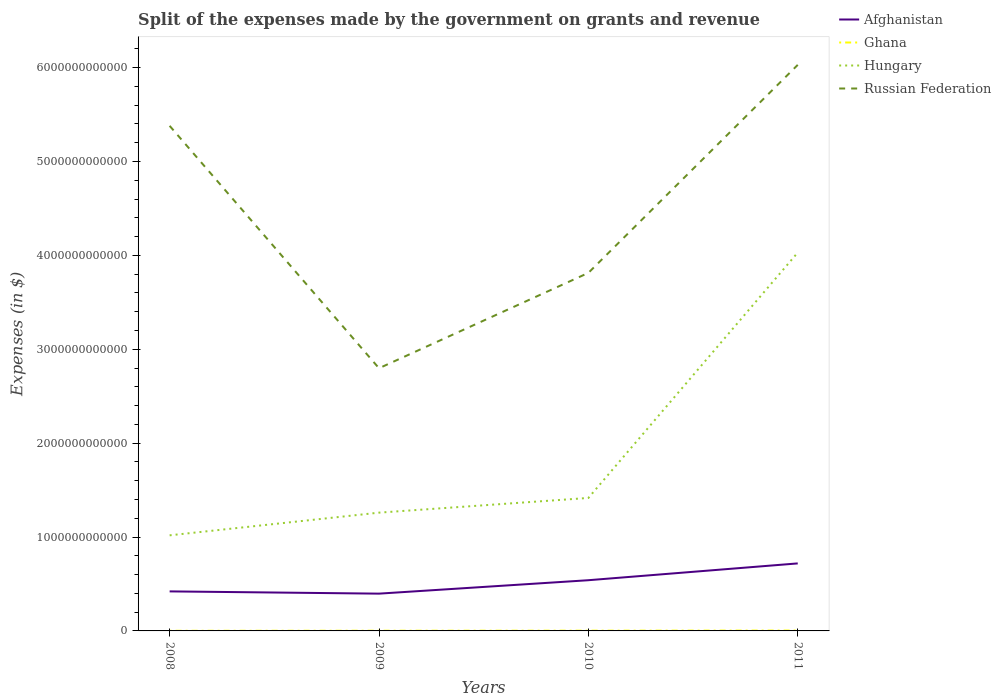How many different coloured lines are there?
Offer a very short reply. 4. Is the number of lines equal to the number of legend labels?
Make the answer very short. Yes. Across all years, what is the maximum expenses made by the government on grants and revenue in Russian Federation?
Provide a succinct answer. 2.80e+12. What is the total expenses made by the government on grants and revenue in Afghanistan in the graph?
Make the answer very short. -1.19e+11. What is the difference between the highest and the second highest expenses made by the government on grants and revenue in Hungary?
Give a very brief answer. 3.01e+12. Is the expenses made by the government on grants and revenue in Russian Federation strictly greater than the expenses made by the government on grants and revenue in Ghana over the years?
Your response must be concise. No. How many lines are there?
Ensure brevity in your answer.  4. What is the difference between two consecutive major ticks on the Y-axis?
Make the answer very short. 1.00e+12. Are the values on the major ticks of Y-axis written in scientific E-notation?
Provide a succinct answer. No. How many legend labels are there?
Provide a succinct answer. 4. What is the title of the graph?
Your response must be concise. Split of the expenses made by the government on grants and revenue. What is the label or title of the X-axis?
Your response must be concise. Years. What is the label or title of the Y-axis?
Provide a short and direct response. Expenses (in $). What is the Expenses (in $) in Afghanistan in 2008?
Offer a very short reply. 4.21e+11. What is the Expenses (in $) in Ghana in 2008?
Your answer should be very brief. 1.44e+09. What is the Expenses (in $) of Hungary in 2008?
Provide a succinct answer. 1.02e+12. What is the Expenses (in $) in Russian Federation in 2008?
Offer a very short reply. 5.38e+12. What is the Expenses (in $) in Afghanistan in 2009?
Give a very brief answer. 3.97e+11. What is the Expenses (in $) in Ghana in 2009?
Offer a very short reply. 2.19e+09. What is the Expenses (in $) of Hungary in 2009?
Give a very brief answer. 1.26e+12. What is the Expenses (in $) of Russian Federation in 2009?
Make the answer very short. 2.80e+12. What is the Expenses (in $) of Afghanistan in 2010?
Your answer should be compact. 5.40e+11. What is the Expenses (in $) in Ghana in 2010?
Offer a terse response. 2.69e+09. What is the Expenses (in $) of Hungary in 2010?
Provide a short and direct response. 1.42e+12. What is the Expenses (in $) of Russian Federation in 2010?
Keep it short and to the point. 3.81e+12. What is the Expenses (in $) of Afghanistan in 2011?
Ensure brevity in your answer.  7.19e+11. What is the Expenses (in $) of Ghana in 2011?
Make the answer very short. 3.96e+09. What is the Expenses (in $) of Hungary in 2011?
Keep it short and to the point. 4.03e+12. What is the Expenses (in $) in Russian Federation in 2011?
Make the answer very short. 6.03e+12. Across all years, what is the maximum Expenses (in $) in Afghanistan?
Give a very brief answer. 7.19e+11. Across all years, what is the maximum Expenses (in $) in Ghana?
Give a very brief answer. 3.96e+09. Across all years, what is the maximum Expenses (in $) of Hungary?
Offer a very short reply. 4.03e+12. Across all years, what is the maximum Expenses (in $) in Russian Federation?
Your response must be concise. 6.03e+12. Across all years, what is the minimum Expenses (in $) of Afghanistan?
Provide a succinct answer. 3.97e+11. Across all years, what is the minimum Expenses (in $) in Ghana?
Your answer should be very brief. 1.44e+09. Across all years, what is the minimum Expenses (in $) in Hungary?
Offer a very short reply. 1.02e+12. Across all years, what is the minimum Expenses (in $) in Russian Federation?
Your response must be concise. 2.80e+12. What is the total Expenses (in $) of Afghanistan in the graph?
Ensure brevity in your answer.  2.08e+12. What is the total Expenses (in $) in Ghana in the graph?
Keep it short and to the point. 1.03e+1. What is the total Expenses (in $) in Hungary in the graph?
Keep it short and to the point. 7.72e+12. What is the total Expenses (in $) of Russian Federation in the graph?
Keep it short and to the point. 1.80e+13. What is the difference between the Expenses (in $) of Afghanistan in 2008 and that in 2009?
Provide a short and direct response. 2.40e+1. What is the difference between the Expenses (in $) in Ghana in 2008 and that in 2009?
Offer a very short reply. -7.46e+08. What is the difference between the Expenses (in $) of Hungary in 2008 and that in 2009?
Offer a very short reply. -2.42e+11. What is the difference between the Expenses (in $) of Russian Federation in 2008 and that in 2009?
Make the answer very short. 2.58e+12. What is the difference between the Expenses (in $) in Afghanistan in 2008 and that in 2010?
Offer a very short reply. -1.19e+11. What is the difference between the Expenses (in $) of Ghana in 2008 and that in 2010?
Your response must be concise. -1.25e+09. What is the difference between the Expenses (in $) of Hungary in 2008 and that in 2010?
Provide a short and direct response. -3.98e+11. What is the difference between the Expenses (in $) of Russian Federation in 2008 and that in 2010?
Make the answer very short. 1.57e+12. What is the difference between the Expenses (in $) in Afghanistan in 2008 and that in 2011?
Make the answer very short. -2.98e+11. What is the difference between the Expenses (in $) of Ghana in 2008 and that in 2011?
Ensure brevity in your answer.  -2.52e+09. What is the difference between the Expenses (in $) of Hungary in 2008 and that in 2011?
Your answer should be very brief. -3.01e+12. What is the difference between the Expenses (in $) in Russian Federation in 2008 and that in 2011?
Keep it short and to the point. -6.49e+11. What is the difference between the Expenses (in $) in Afghanistan in 2009 and that in 2010?
Your answer should be compact. -1.43e+11. What is the difference between the Expenses (in $) of Ghana in 2009 and that in 2010?
Keep it short and to the point. -5.08e+08. What is the difference between the Expenses (in $) of Hungary in 2009 and that in 2010?
Ensure brevity in your answer.  -1.57e+11. What is the difference between the Expenses (in $) of Russian Federation in 2009 and that in 2010?
Keep it short and to the point. -1.02e+12. What is the difference between the Expenses (in $) in Afghanistan in 2009 and that in 2011?
Your answer should be compact. -3.22e+11. What is the difference between the Expenses (in $) in Ghana in 2009 and that in 2011?
Your response must be concise. -1.78e+09. What is the difference between the Expenses (in $) in Hungary in 2009 and that in 2011?
Your answer should be very brief. -2.77e+12. What is the difference between the Expenses (in $) in Russian Federation in 2009 and that in 2011?
Ensure brevity in your answer.  -3.23e+12. What is the difference between the Expenses (in $) in Afghanistan in 2010 and that in 2011?
Give a very brief answer. -1.79e+11. What is the difference between the Expenses (in $) of Ghana in 2010 and that in 2011?
Offer a very short reply. -1.27e+09. What is the difference between the Expenses (in $) in Hungary in 2010 and that in 2011?
Offer a terse response. -2.61e+12. What is the difference between the Expenses (in $) in Russian Federation in 2010 and that in 2011?
Give a very brief answer. -2.22e+12. What is the difference between the Expenses (in $) of Afghanistan in 2008 and the Expenses (in $) of Ghana in 2009?
Ensure brevity in your answer.  4.19e+11. What is the difference between the Expenses (in $) of Afghanistan in 2008 and the Expenses (in $) of Hungary in 2009?
Provide a short and direct response. -8.39e+11. What is the difference between the Expenses (in $) in Afghanistan in 2008 and the Expenses (in $) in Russian Federation in 2009?
Make the answer very short. -2.38e+12. What is the difference between the Expenses (in $) in Ghana in 2008 and the Expenses (in $) in Hungary in 2009?
Your answer should be compact. -1.26e+12. What is the difference between the Expenses (in $) in Ghana in 2008 and the Expenses (in $) in Russian Federation in 2009?
Your answer should be compact. -2.80e+12. What is the difference between the Expenses (in $) of Hungary in 2008 and the Expenses (in $) of Russian Federation in 2009?
Your answer should be compact. -1.78e+12. What is the difference between the Expenses (in $) of Afghanistan in 2008 and the Expenses (in $) of Ghana in 2010?
Make the answer very short. 4.18e+11. What is the difference between the Expenses (in $) in Afghanistan in 2008 and the Expenses (in $) in Hungary in 2010?
Make the answer very short. -9.95e+11. What is the difference between the Expenses (in $) of Afghanistan in 2008 and the Expenses (in $) of Russian Federation in 2010?
Provide a short and direct response. -3.39e+12. What is the difference between the Expenses (in $) of Ghana in 2008 and the Expenses (in $) of Hungary in 2010?
Keep it short and to the point. -1.42e+12. What is the difference between the Expenses (in $) of Ghana in 2008 and the Expenses (in $) of Russian Federation in 2010?
Ensure brevity in your answer.  -3.81e+12. What is the difference between the Expenses (in $) in Hungary in 2008 and the Expenses (in $) in Russian Federation in 2010?
Make the answer very short. -2.80e+12. What is the difference between the Expenses (in $) of Afghanistan in 2008 and the Expenses (in $) of Ghana in 2011?
Provide a short and direct response. 4.17e+11. What is the difference between the Expenses (in $) of Afghanistan in 2008 and the Expenses (in $) of Hungary in 2011?
Your answer should be very brief. -3.61e+12. What is the difference between the Expenses (in $) in Afghanistan in 2008 and the Expenses (in $) in Russian Federation in 2011?
Your response must be concise. -5.61e+12. What is the difference between the Expenses (in $) in Ghana in 2008 and the Expenses (in $) in Hungary in 2011?
Make the answer very short. -4.03e+12. What is the difference between the Expenses (in $) in Ghana in 2008 and the Expenses (in $) in Russian Federation in 2011?
Offer a terse response. -6.03e+12. What is the difference between the Expenses (in $) in Hungary in 2008 and the Expenses (in $) in Russian Federation in 2011?
Offer a very short reply. -5.01e+12. What is the difference between the Expenses (in $) in Afghanistan in 2009 and the Expenses (in $) in Ghana in 2010?
Keep it short and to the point. 3.94e+11. What is the difference between the Expenses (in $) of Afghanistan in 2009 and the Expenses (in $) of Hungary in 2010?
Your answer should be very brief. -1.02e+12. What is the difference between the Expenses (in $) of Afghanistan in 2009 and the Expenses (in $) of Russian Federation in 2010?
Offer a terse response. -3.42e+12. What is the difference between the Expenses (in $) in Ghana in 2009 and the Expenses (in $) in Hungary in 2010?
Give a very brief answer. -1.41e+12. What is the difference between the Expenses (in $) of Ghana in 2009 and the Expenses (in $) of Russian Federation in 2010?
Make the answer very short. -3.81e+12. What is the difference between the Expenses (in $) in Hungary in 2009 and the Expenses (in $) in Russian Federation in 2010?
Make the answer very short. -2.55e+12. What is the difference between the Expenses (in $) of Afghanistan in 2009 and the Expenses (in $) of Ghana in 2011?
Provide a succinct answer. 3.93e+11. What is the difference between the Expenses (in $) in Afghanistan in 2009 and the Expenses (in $) in Hungary in 2011?
Offer a very short reply. -3.63e+12. What is the difference between the Expenses (in $) of Afghanistan in 2009 and the Expenses (in $) of Russian Federation in 2011?
Your answer should be very brief. -5.63e+12. What is the difference between the Expenses (in $) of Ghana in 2009 and the Expenses (in $) of Hungary in 2011?
Your response must be concise. -4.03e+12. What is the difference between the Expenses (in $) of Ghana in 2009 and the Expenses (in $) of Russian Federation in 2011?
Make the answer very short. -6.03e+12. What is the difference between the Expenses (in $) in Hungary in 2009 and the Expenses (in $) in Russian Federation in 2011?
Offer a terse response. -4.77e+12. What is the difference between the Expenses (in $) in Afghanistan in 2010 and the Expenses (in $) in Ghana in 2011?
Provide a succinct answer. 5.36e+11. What is the difference between the Expenses (in $) of Afghanistan in 2010 and the Expenses (in $) of Hungary in 2011?
Provide a succinct answer. -3.49e+12. What is the difference between the Expenses (in $) of Afghanistan in 2010 and the Expenses (in $) of Russian Federation in 2011?
Your response must be concise. -5.49e+12. What is the difference between the Expenses (in $) in Ghana in 2010 and the Expenses (in $) in Hungary in 2011?
Provide a short and direct response. -4.03e+12. What is the difference between the Expenses (in $) of Ghana in 2010 and the Expenses (in $) of Russian Federation in 2011?
Offer a very short reply. -6.03e+12. What is the difference between the Expenses (in $) in Hungary in 2010 and the Expenses (in $) in Russian Federation in 2011?
Offer a terse response. -4.61e+12. What is the average Expenses (in $) in Afghanistan per year?
Give a very brief answer. 5.19e+11. What is the average Expenses (in $) of Ghana per year?
Ensure brevity in your answer.  2.57e+09. What is the average Expenses (in $) of Hungary per year?
Make the answer very short. 1.93e+12. What is the average Expenses (in $) of Russian Federation per year?
Provide a succinct answer. 4.51e+12. In the year 2008, what is the difference between the Expenses (in $) of Afghanistan and Expenses (in $) of Ghana?
Make the answer very short. 4.20e+11. In the year 2008, what is the difference between the Expenses (in $) of Afghanistan and Expenses (in $) of Hungary?
Make the answer very short. -5.97e+11. In the year 2008, what is the difference between the Expenses (in $) in Afghanistan and Expenses (in $) in Russian Federation?
Your answer should be very brief. -4.96e+12. In the year 2008, what is the difference between the Expenses (in $) in Ghana and Expenses (in $) in Hungary?
Your response must be concise. -1.02e+12. In the year 2008, what is the difference between the Expenses (in $) of Ghana and Expenses (in $) of Russian Federation?
Offer a terse response. -5.38e+12. In the year 2008, what is the difference between the Expenses (in $) of Hungary and Expenses (in $) of Russian Federation?
Make the answer very short. -4.36e+12. In the year 2009, what is the difference between the Expenses (in $) of Afghanistan and Expenses (in $) of Ghana?
Ensure brevity in your answer.  3.95e+11. In the year 2009, what is the difference between the Expenses (in $) of Afghanistan and Expenses (in $) of Hungary?
Make the answer very short. -8.63e+11. In the year 2009, what is the difference between the Expenses (in $) of Afghanistan and Expenses (in $) of Russian Federation?
Make the answer very short. -2.40e+12. In the year 2009, what is the difference between the Expenses (in $) of Ghana and Expenses (in $) of Hungary?
Your answer should be very brief. -1.26e+12. In the year 2009, what is the difference between the Expenses (in $) of Ghana and Expenses (in $) of Russian Federation?
Provide a short and direct response. -2.80e+12. In the year 2009, what is the difference between the Expenses (in $) in Hungary and Expenses (in $) in Russian Federation?
Provide a succinct answer. -1.54e+12. In the year 2010, what is the difference between the Expenses (in $) in Afghanistan and Expenses (in $) in Ghana?
Provide a short and direct response. 5.37e+11. In the year 2010, what is the difference between the Expenses (in $) in Afghanistan and Expenses (in $) in Hungary?
Ensure brevity in your answer.  -8.76e+11. In the year 2010, what is the difference between the Expenses (in $) of Afghanistan and Expenses (in $) of Russian Federation?
Your response must be concise. -3.27e+12. In the year 2010, what is the difference between the Expenses (in $) in Ghana and Expenses (in $) in Hungary?
Provide a succinct answer. -1.41e+12. In the year 2010, what is the difference between the Expenses (in $) in Ghana and Expenses (in $) in Russian Federation?
Provide a short and direct response. -3.81e+12. In the year 2010, what is the difference between the Expenses (in $) of Hungary and Expenses (in $) of Russian Federation?
Give a very brief answer. -2.40e+12. In the year 2011, what is the difference between the Expenses (in $) in Afghanistan and Expenses (in $) in Ghana?
Ensure brevity in your answer.  7.15e+11. In the year 2011, what is the difference between the Expenses (in $) of Afghanistan and Expenses (in $) of Hungary?
Your response must be concise. -3.31e+12. In the year 2011, what is the difference between the Expenses (in $) in Afghanistan and Expenses (in $) in Russian Federation?
Your response must be concise. -5.31e+12. In the year 2011, what is the difference between the Expenses (in $) in Ghana and Expenses (in $) in Hungary?
Your response must be concise. -4.03e+12. In the year 2011, what is the difference between the Expenses (in $) in Ghana and Expenses (in $) in Russian Federation?
Your answer should be very brief. -6.03e+12. In the year 2011, what is the difference between the Expenses (in $) of Hungary and Expenses (in $) of Russian Federation?
Your answer should be very brief. -2.00e+12. What is the ratio of the Expenses (in $) in Afghanistan in 2008 to that in 2009?
Offer a very short reply. 1.06. What is the ratio of the Expenses (in $) in Ghana in 2008 to that in 2009?
Offer a very short reply. 0.66. What is the ratio of the Expenses (in $) in Hungary in 2008 to that in 2009?
Keep it short and to the point. 0.81. What is the ratio of the Expenses (in $) of Russian Federation in 2008 to that in 2009?
Provide a succinct answer. 1.92. What is the ratio of the Expenses (in $) in Afghanistan in 2008 to that in 2010?
Offer a very short reply. 0.78. What is the ratio of the Expenses (in $) in Ghana in 2008 to that in 2010?
Your answer should be compact. 0.53. What is the ratio of the Expenses (in $) in Hungary in 2008 to that in 2010?
Ensure brevity in your answer.  0.72. What is the ratio of the Expenses (in $) of Russian Federation in 2008 to that in 2010?
Provide a succinct answer. 1.41. What is the ratio of the Expenses (in $) in Afghanistan in 2008 to that in 2011?
Make the answer very short. 0.59. What is the ratio of the Expenses (in $) of Ghana in 2008 to that in 2011?
Provide a succinct answer. 0.36. What is the ratio of the Expenses (in $) in Hungary in 2008 to that in 2011?
Offer a terse response. 0.25. What is the ratio of the Expenses (in $) of Russian Federation in 2008 to that in 2011?
Offer a very short reply. 0.89. What is the ratio of the Expenses (in $) of Afghanistan in 2009 to that in 2010?
Offer a very short reply. 0.74. What is the ratio of the Expenses (in $) in Ghana in 2009 to that in 2010?
Provide a succinct answer. 0.81. What is the ratio of the Expenses (in $) of Hungary in 2009 to that in 2010?
Offer a very short reply. 0.89. What is the ratio of the Expenses (in $) in Russian Federation in 2009 to that in 2010?
Offer a terse response. 0.73. What is the ratio of the Expenses (in $) of Afghanistan in 2009 to that in 2011?
Offer a terse response. 0.55. What is the ratio of the Expenses (in $) of Ghana in 2009 to that in 2011?
Offer a very short reply. 0.55. What is the ratio of the Expenses (in $) of Hungary in 2009 to that in 2011?
Provide a succinct answer. 0.31. What is the ratio of the Expenses (in $) in Russian Federation in 2009 to that in 2011?
Ensure brevity in your answer.  0.46. What is the ratio of the Expenses (in $) of Afghanistan in 2010 to that in 2011?
Provide a succinct answer. 0.75. What is the ratio of the Expenses (in $) of Ghana in 2010 to that in 2011?
Ensure brevity in your answer.  0.68. What is the ratio of the Expenses (in $) of Hungary in 2010 to that in 2011?
Offer a terse response. 0.35. What is the ratio of the Expenses (in $) in Russian Federation in 2010 to that in 2011?
Your response must be concise. 0.63. What is the difference between the highest and the second highest Expenses (in $) of Afghanistan?
Offer a very short reply. 1.79e+11. What is the difference between the highest and the second highest Expenses (in $) in Ghana?
Provide a succinct answer. 1.27e+09. What is the difference between the highest and the second highest Expenses (in $) of Hungary?
Your response must be concise. 2.61e+12. What is the difference between the highest and the second highest Expenses (in $) in Russian Federation?
Offer a terse response. 6.49e+11. What is the difference between the highest and the lowest Expenses (in $) of Afghanistan?
Your answer should be very brief. 3.22e+11. What is the difference between the highest and the lowest Expenses (in $) of Ghana?
Provide a short and direct response. 2.52e+09. What is the difference between the highest and the lowest Expenses (in $) in Hungary?
Your response must be concise. 3.01e+12. What is the difference between the highest and the lowest Expenses (in $) of Russian Federation?
Make the answer very short. 3.23e+12. 